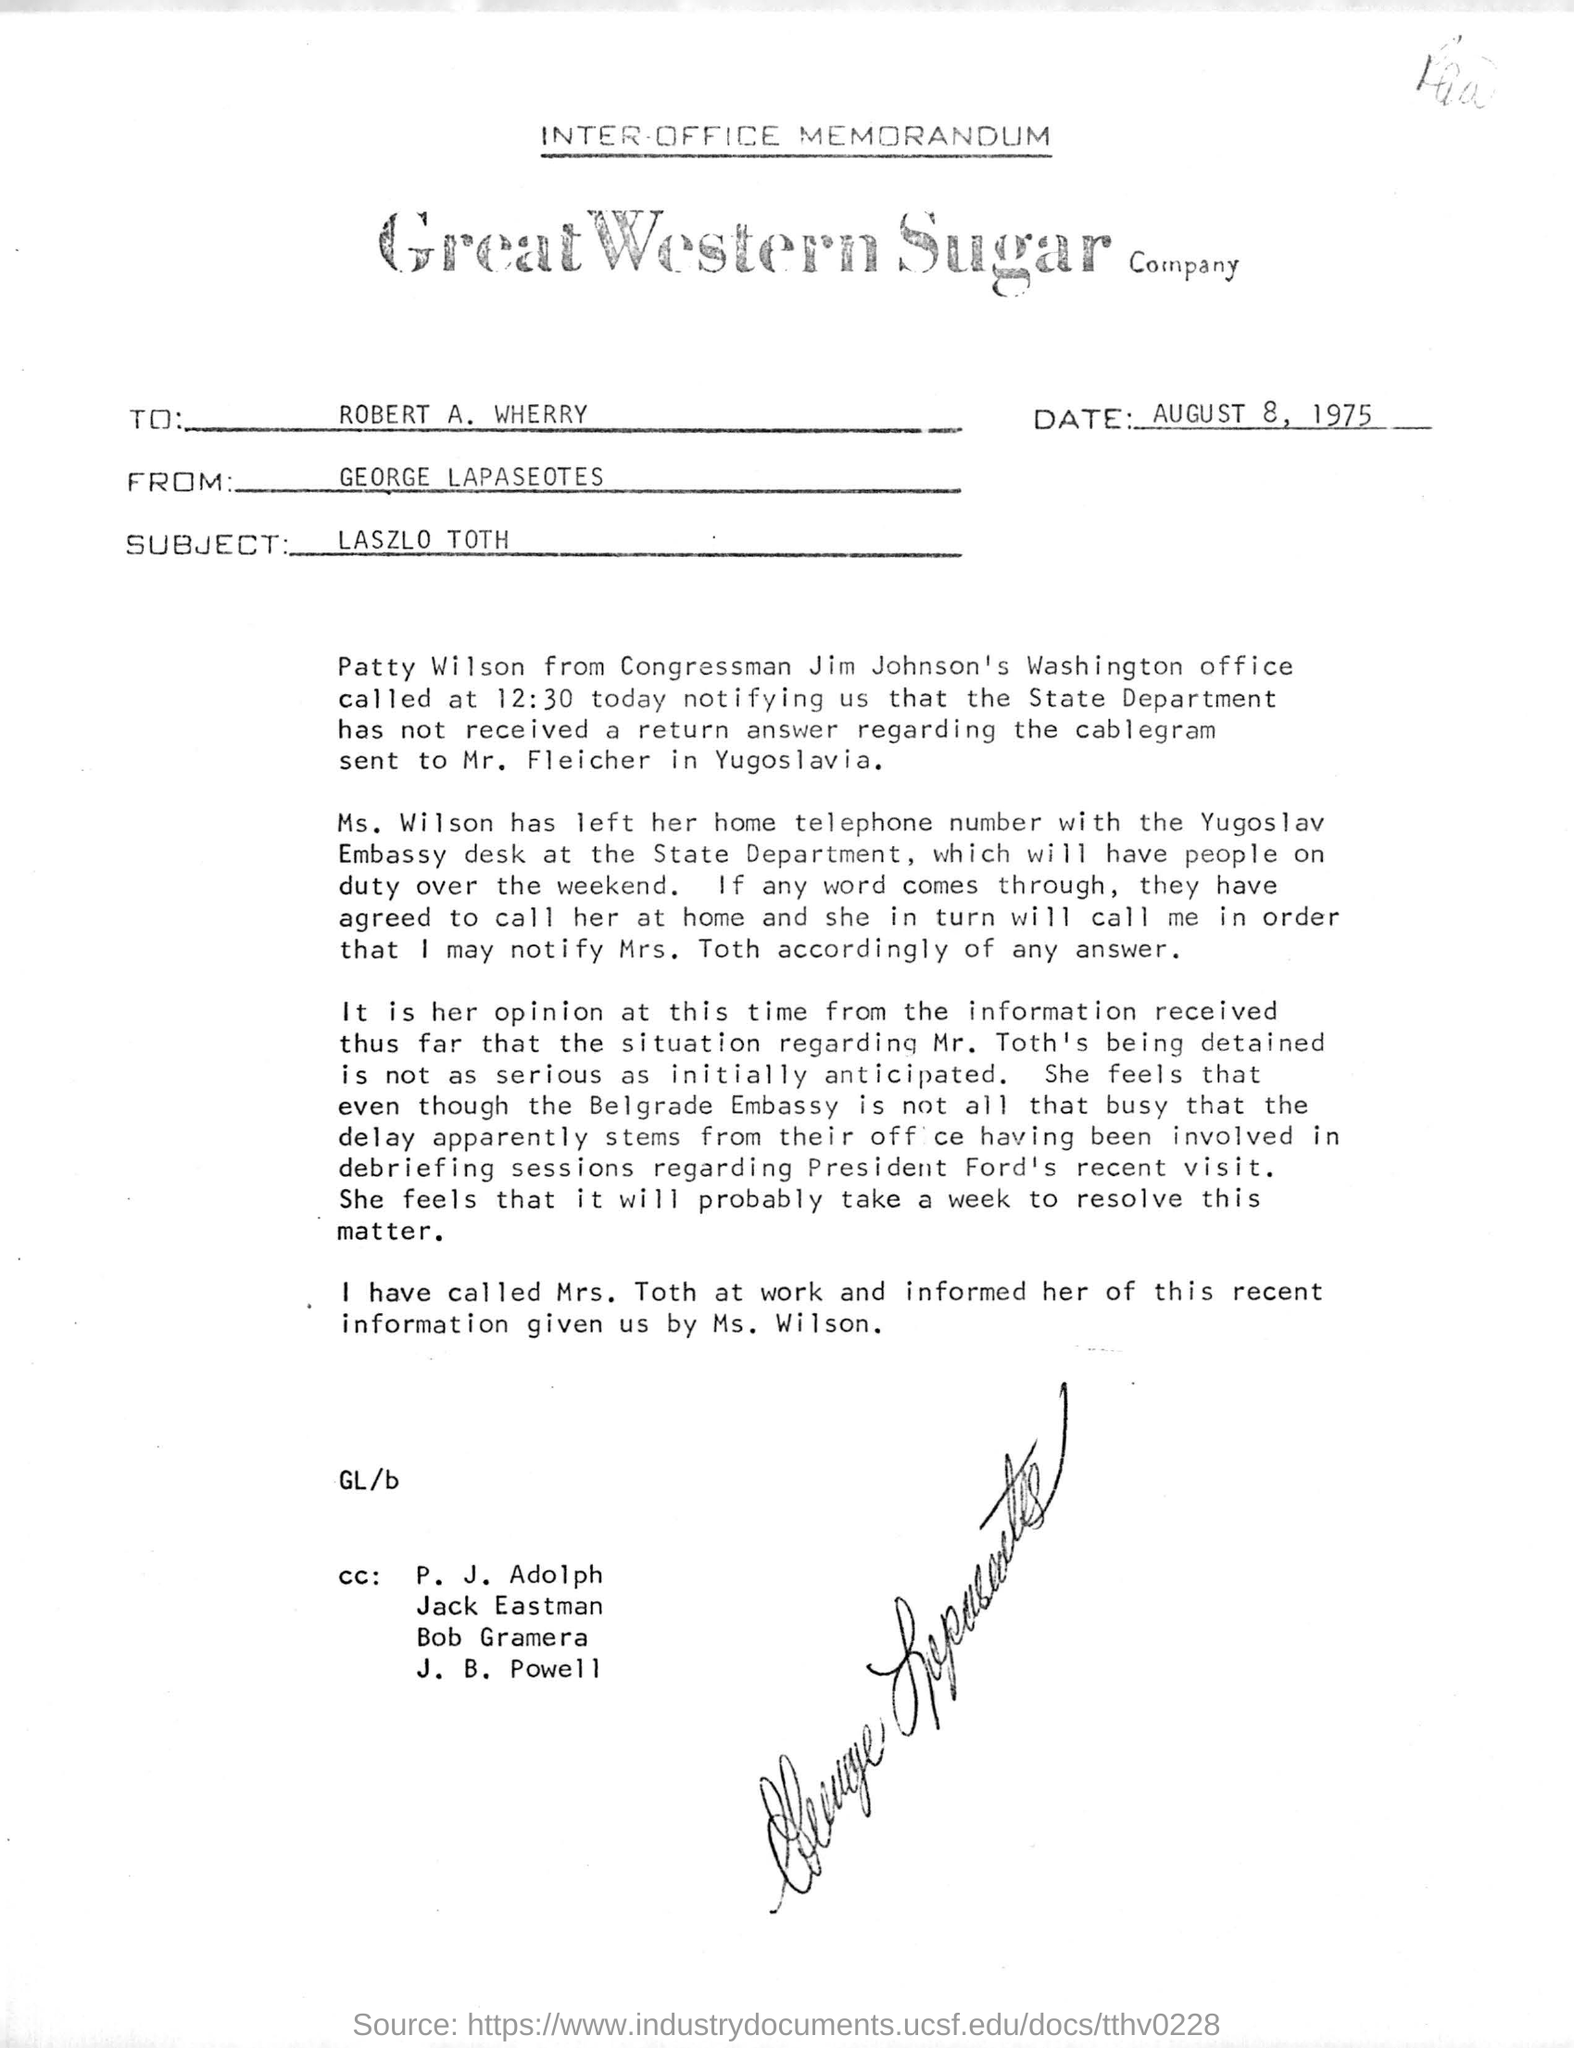Who is the memorandum from?
Your response must be concise. GEORGE LAPASEOTES. What is the subject of the memorandum?
Keep it short and to the point. LASZLO TOTH. When is the memorandum dated on?
Keep it short and to the point. August 8, 1975. 